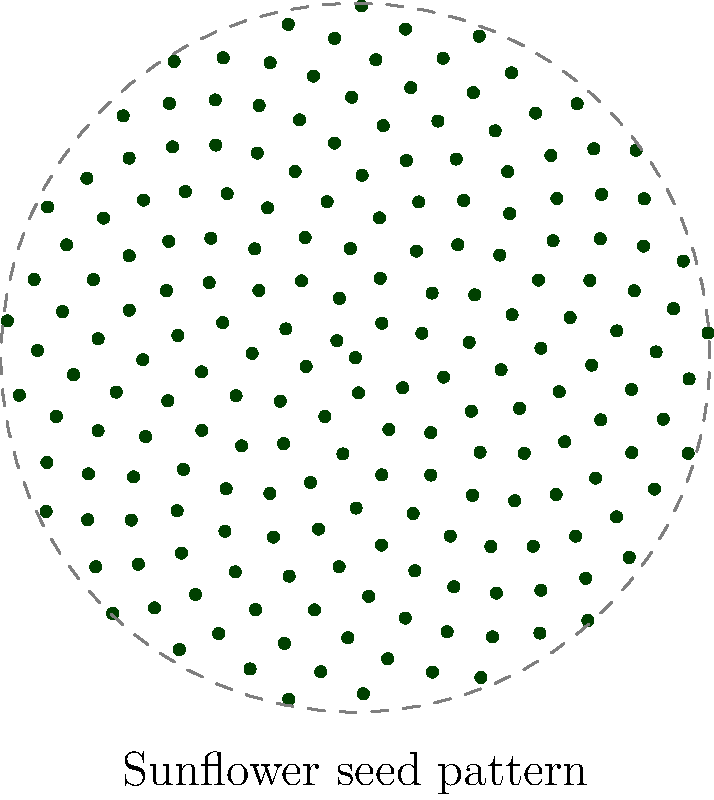In the polar coordinate representation of a sunflower's seed arrangement, which literary concept does the spiraling pattern most closely resemble, and how might this connection inspire nature-based poetry? To answer this question, let's break it down step-by-step:

1. Observe the spiral pattern: The image shows seeds arranged in a spiral pattern, following the golden angle (approximately 137.5 degrees).

2. Literary concept connection: This pattern closely resembles the concept of the "golden spiral" or "Fibonacci spiral," which is often associated with the idea of natural harmony and balance in literature.

3. Relevance to nature-inspired literature:
   a) The spiral pattern represents growth and evolution, common themes in nature poetry.
   b) It symbolizes the interconnectedness of all things in nature, a concept explored in Romantic and Transcendentalist literature.
   c) The mathematical precision of the pattern can inspire reflections on the hidden order in seemingly chaotic natural phenomena.

4. Poetic inspiration:
   a) The spiral could be used as a metaphor for life cycles or personal growth in poetry.
   b) It could inspire structured poems that mirror the mathematical pattern, such as syllabic or spiral-form poetry.
   c) The visual beauty of the pattern could be described using rich, nature-based imagery in descriptive poetry.

5. Connection to specific literary movements:
   a) Romantic poets like William Wordsworth often found inspiration in nature's patterns.
   b) Modernist poets like Wallace Stevens explored the intersection of nature and human perception.

In conclusion, the sunflower's seed arrangement, represented by the spiral pattern, most closely resembles the golden spiral concept in literature. This pattern can inspire nature-based poetry by providing a visual representation of growth, interconnectedness, and hidden order in nature, which poets can explore through metaphor, structure, and imagery.
Answer: Golden spiral; inspires exploration of growth, interconnectedness, and hidden order in nature poetry. 